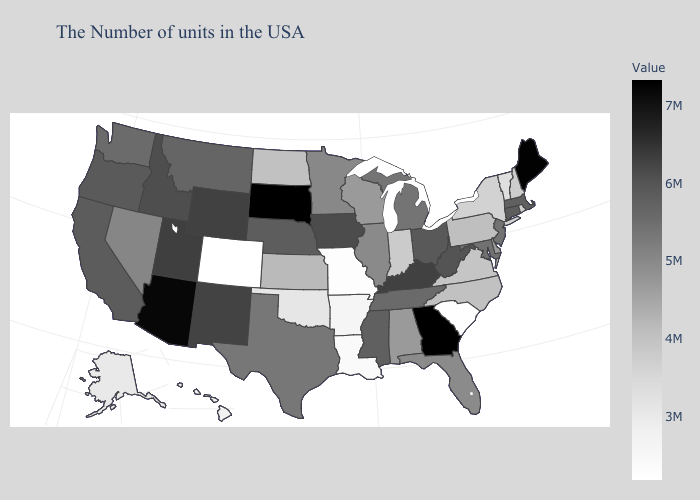Which states have the lowest value in the USA?
Quick response, please. Colorado. Among the states that border Illinois , does Missouri have the lowest value?
Write a very short answer. Yes. Which states have the lowest value in the South?
Write a very short answer. South Carolina. Which states have the highest value in the USA?
Concise answer only. Georgia. Does Kansas have the lowest value in the MidWest?
Keep it brief. No. Is the legend a continuous bar?
Be succinct. Yes. 